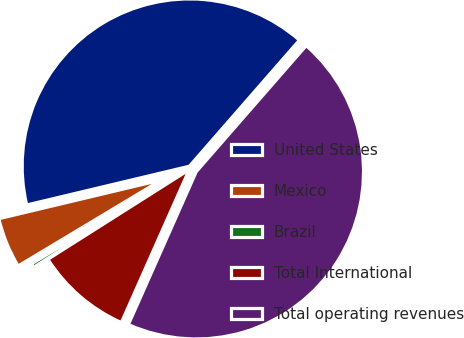<chart> <loc_0><loc_0><loc_500><loc_500><pie_chart><fcel>United States<fcel>Mexico<fcel>Brazil<fcel>Total International<fcel>Total operating revenues<nl><fcel>40.14%<fcel>4.88%<fcel>0.39%<fcel>9.36%<fcel>45.23%<nl></chart> 